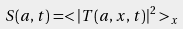<formula> <loc_0><loc_0><loc_500><loc_500>S ( a , t ) = < | T ( a , x , t ) | ^ { 2 } > _ { x }</formula> 